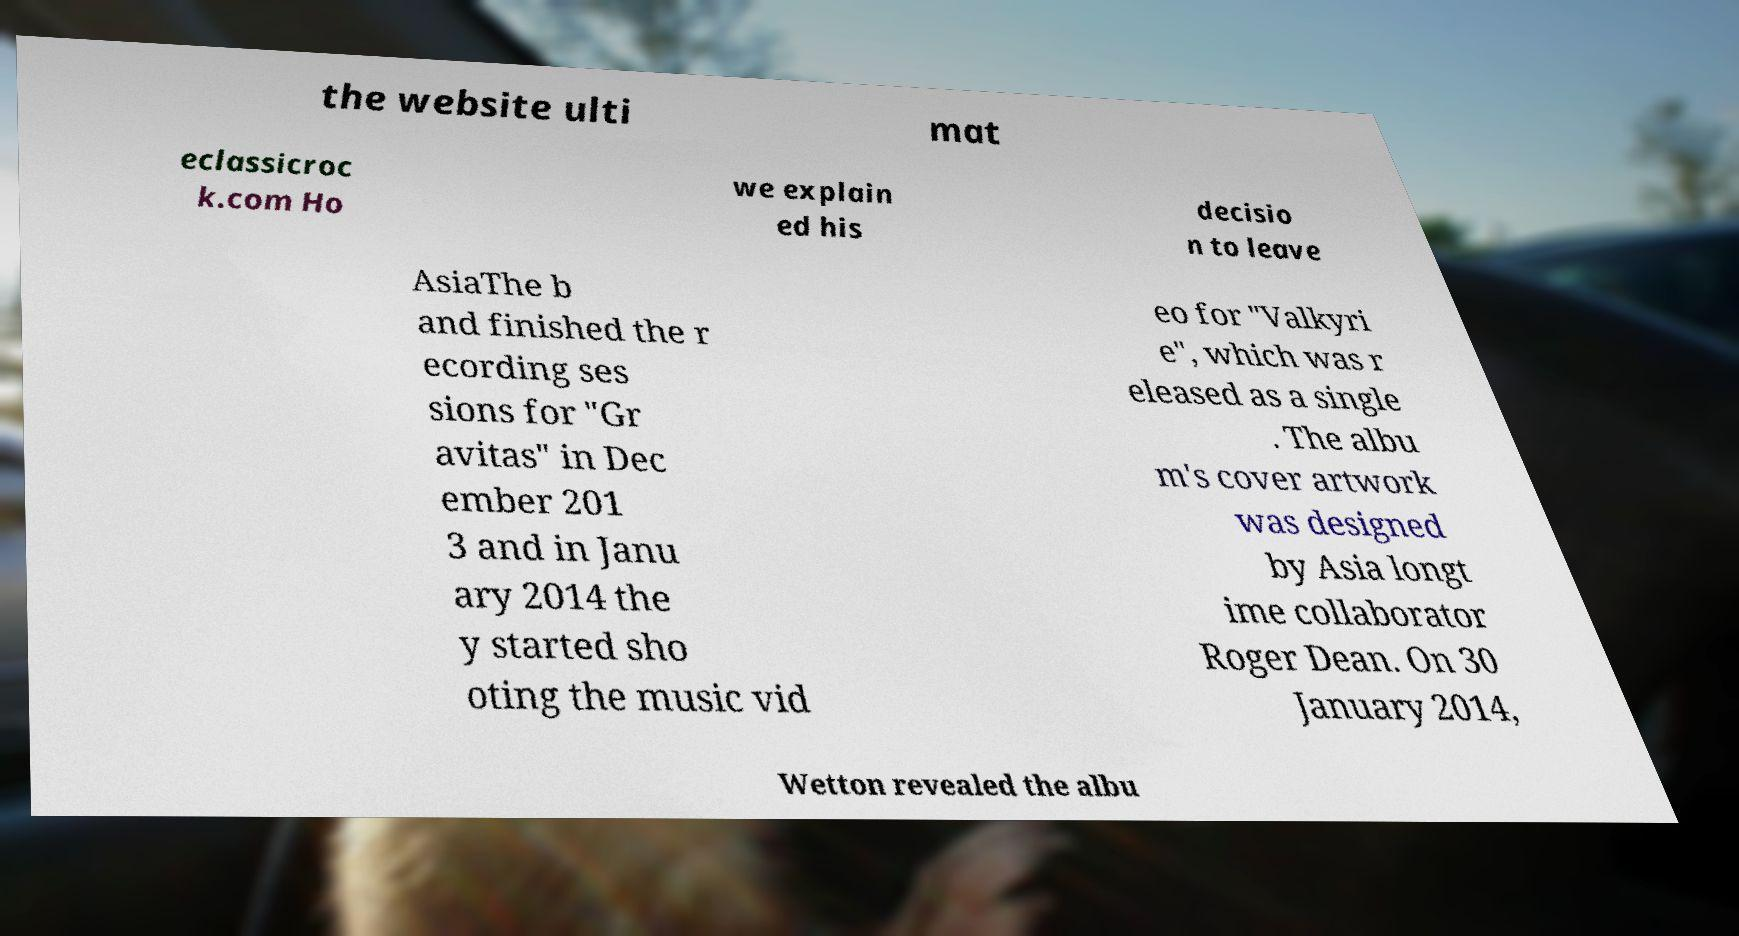Please identify and transcribe the text found in this image. the website ulti mat eclassicroc k.com Ho we explain ed his decisio n to leave AsiaThe b and finished the r ecording ses sions for "Gr avitas" in Dec ember 201 3 and in Janu ary 2014 the y started sho oting the music vid eo for "Valkyri e", which was r eleased as a single . The albu m's cover artwork was designed by Asia longt ime collaborator Roger Dean. On 30 January 2014, Wetton revealed the albu 